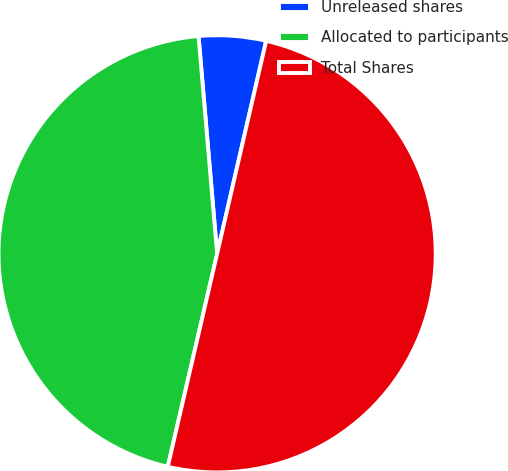Convert chart. <chart><loc_0><loc_0><loc_500><loc_500><pie_chart><fcel>Unreleased shares<fcel>Allocated to participants<fcel>Total Shares<nl><fcel>4.96%<fcel>45.02%<fcel>50.02%<nl></chart> 